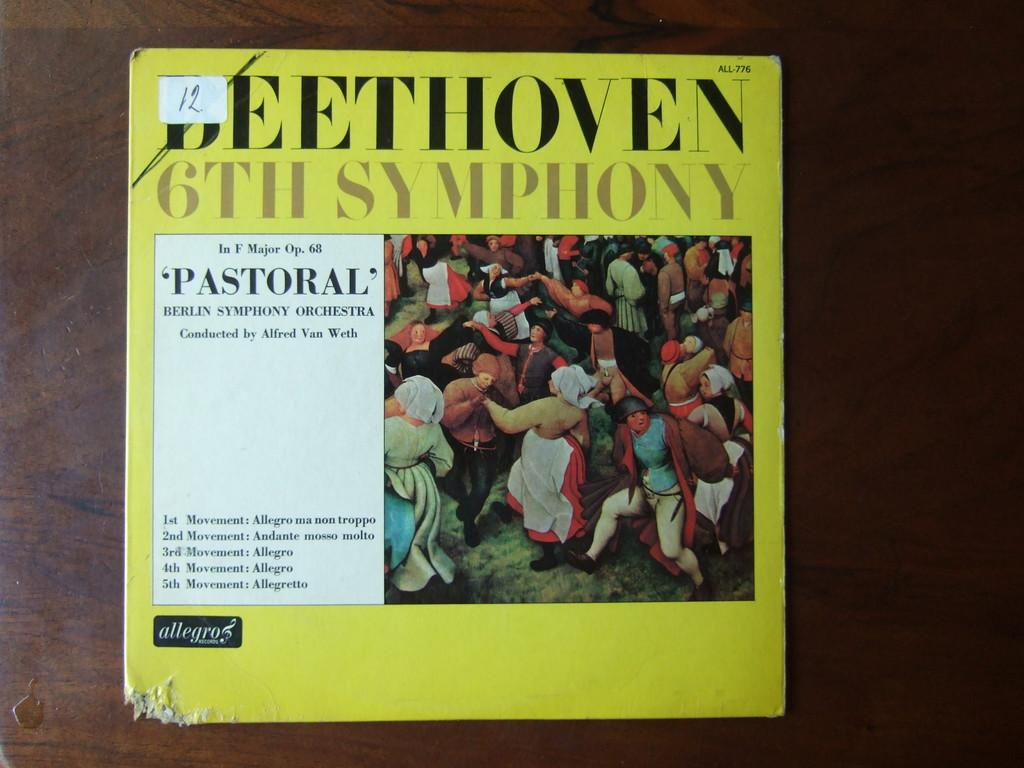<image>
Summarize the visual content of the image. A yellow score book of Beethoven's Pastoral Symphony is on a table. 